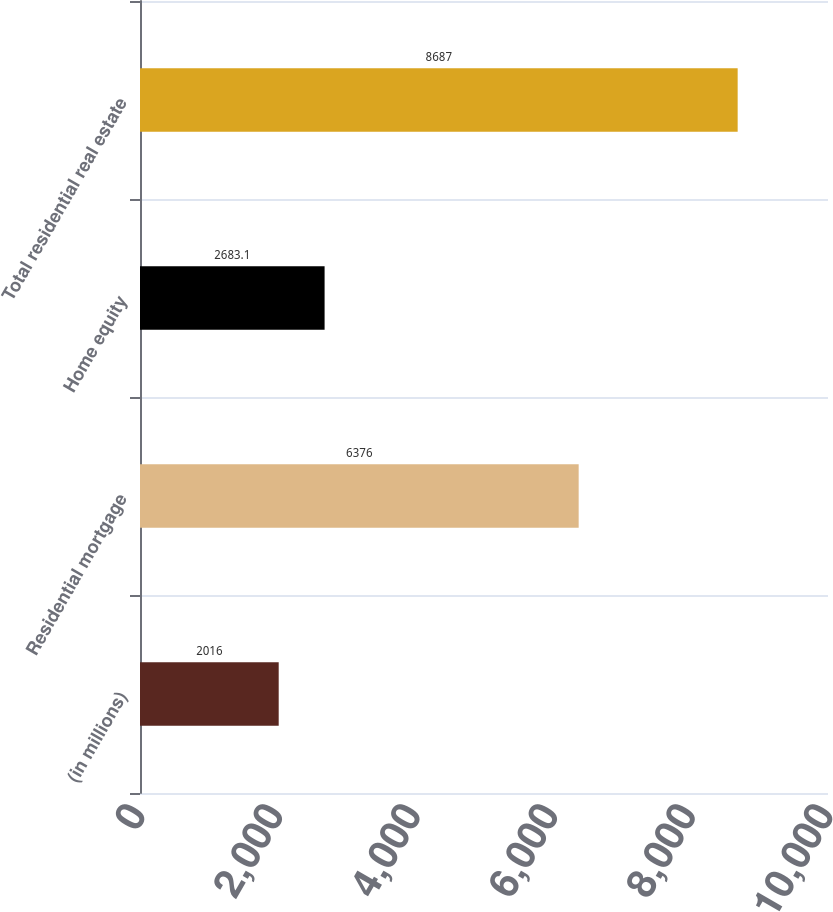Convert chart. <chart><loc_0><loc_0><loc_500><loc_500><bar_chart><fcel>(in millions)<fcel>Residential mortgage<fcel>Home equity<fcel>Total residential real estate<nl><fcel>2016<fcel>6376<fcel>2683.1<fcel>8687<nl></chart> 